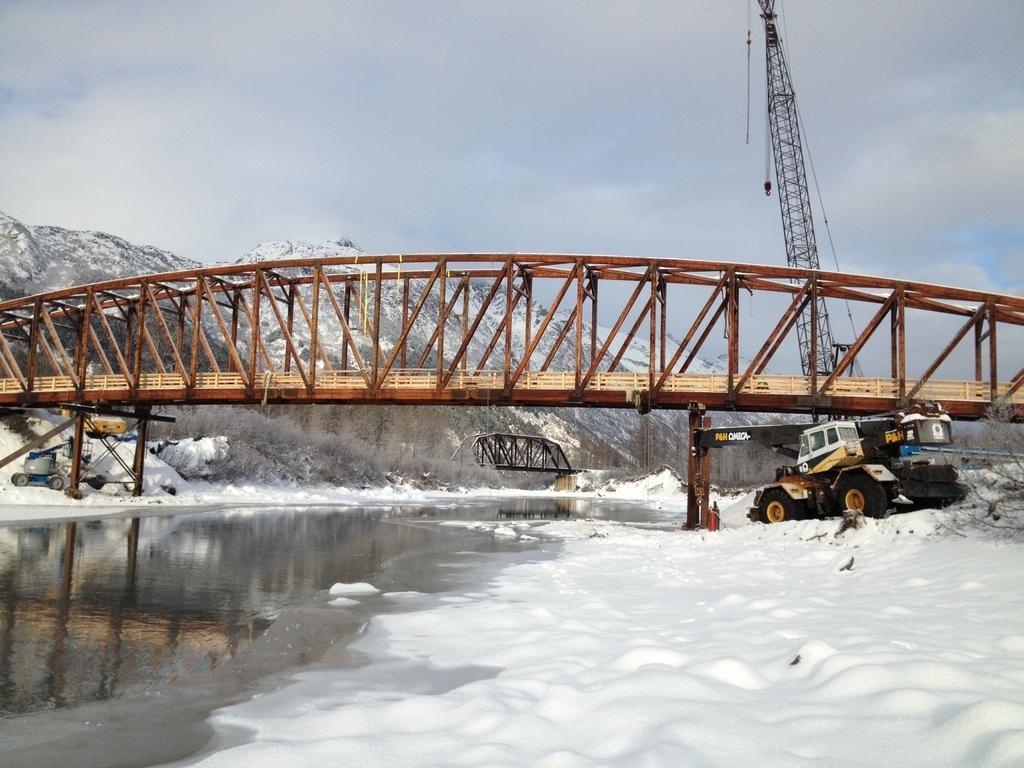In one or two sentences, can you explain what this image depicts? This is an outside view. On the left side, I can see the water on the ground and on the right side, I can see the snow. In the background there is a bridge and a crane. Along with this I can see few vehicles on the snow. In the background, I can see some trees and the hills. On the top of the image I can see the sky. 